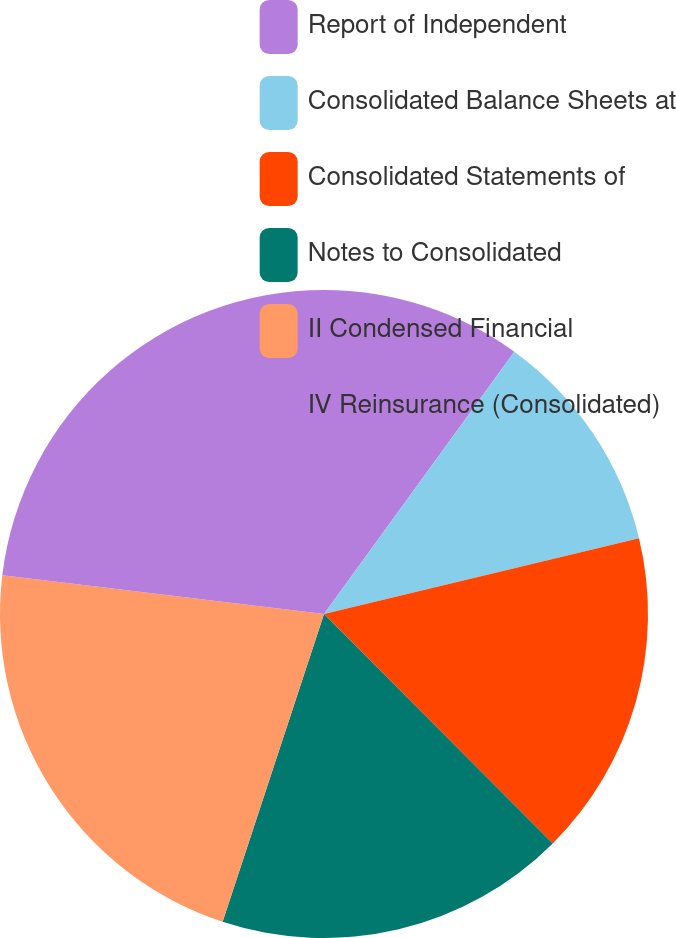<chart> <loc_0><loc_0><loc_500><loc_500><pie_chart><fcel>Report of Independent<fcel>Consolidated Balance Sheets at<fcel>Consolidated Statements of<fcel>Notes to Consolidated<fcel>II Condensed Financial<fcel>IV Reinsurance (Consolidated)<nl><fcel>9.99%<fcel>11.25%<fcel>16.28%<fcel>17.54%<fcel>21.84%<fcel>23.09%<nl></chart> 